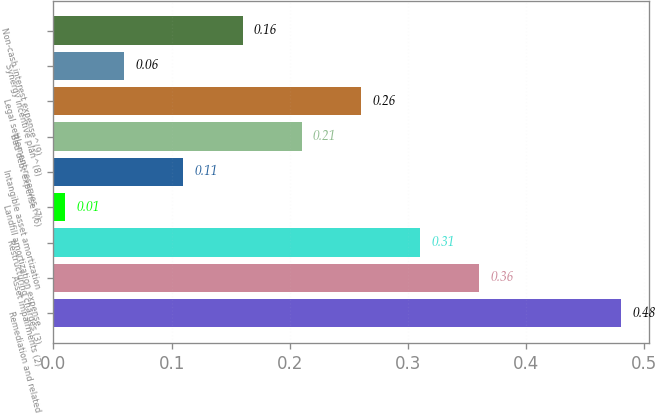<chart> <loc_0><loc_0><loc_500><loc_500><bar_chart><fcel>Remediation and related<fcel>Asset impairments (2)<fcel>Restructuring charges (3)<fcel>Landfill amortization expense<fcel>Intangible asset amortization<fcel>Bad debt expense^(6)<fcel>Legal settlement reserves (7)<fcel>Synergy incentive plan^(8)<fcel>Non-cash interest expense^(9)<nl><fcel>0.48<fcel>0.36<fcel>0.31<fcel>0.01<fcel>0.11<fcel>0.21<fcel>0.26<fcel>0.06<fcel>0.16<nl></chart> 